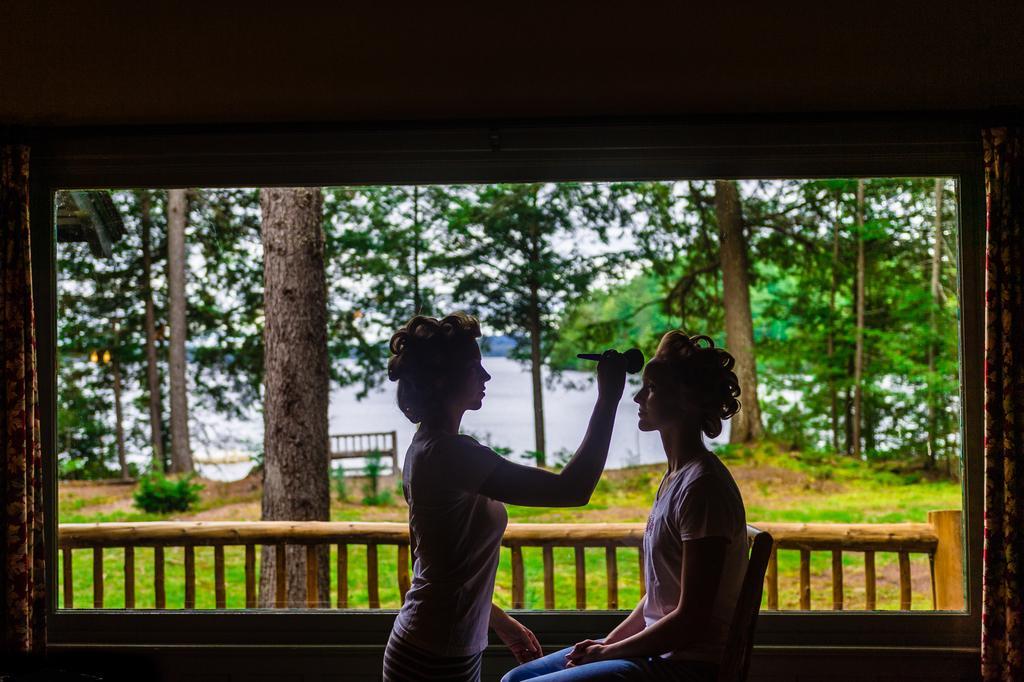In one or two sentences, can you explain what this image depicts? In this picture we can see two people and in the background we can see a fence, trees, water, bench and the sky. 